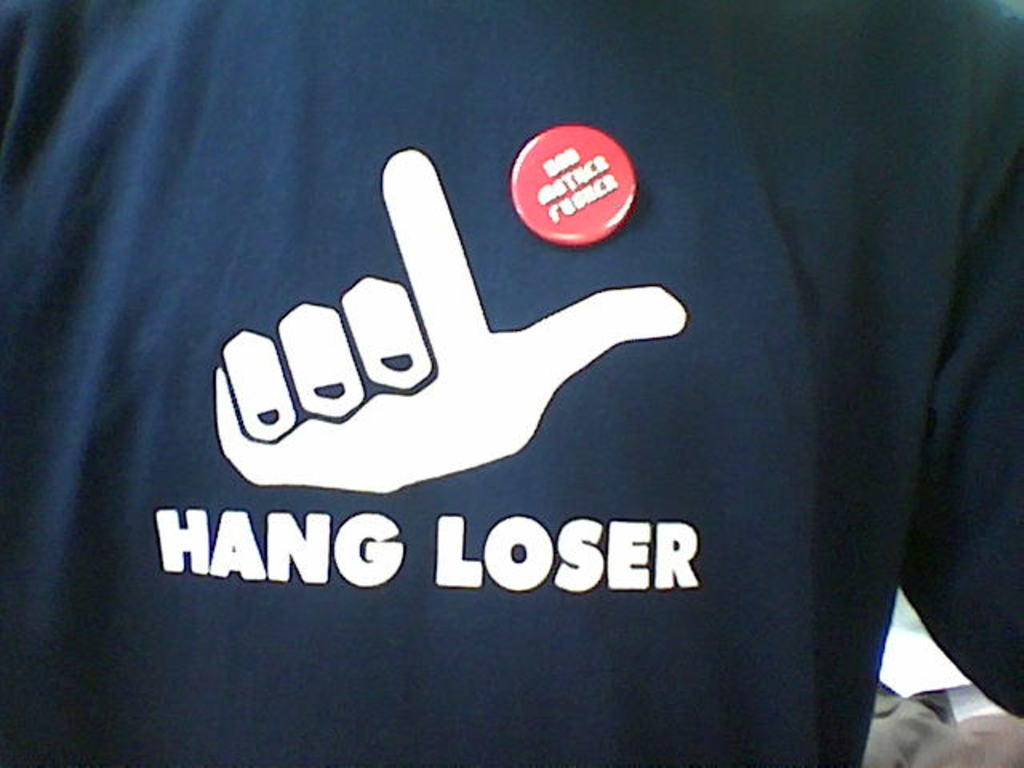Can you describe the main features of this image for me? The image features a person wearing a navy blue t-shirt that displays a white graphic of a hand making the "hang loose" gesture. The words "HANG LOSER" are written below the graphic in white. This could suggest a playful or sarcastic tone. Additionally, the person is wearing a red button that reads "I'm with stupid", a phrase often used humorously to tease or joke with others. The combination of these elements indicates a sense of humor and a casual, laid-back style. 